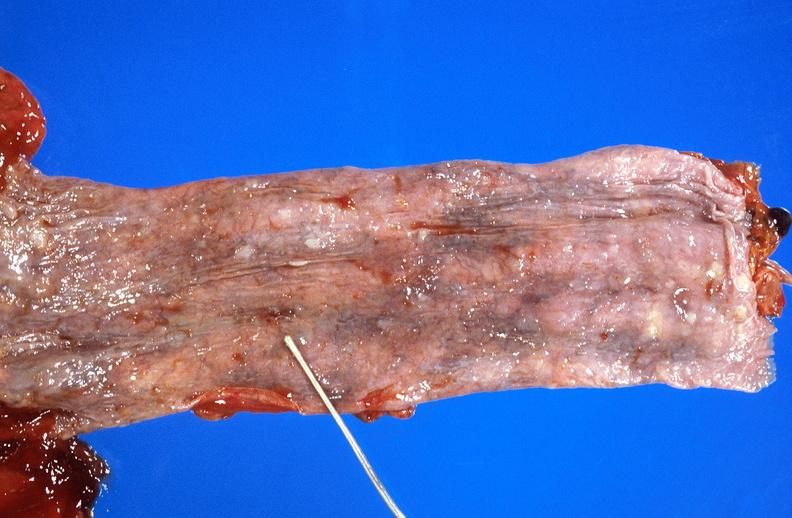s gastrointestinal present?
Answer the question using a single word or phrase. Yes 